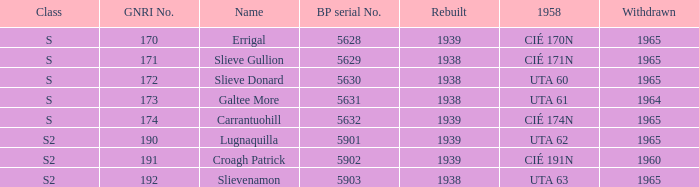What is the smallest withdrawn value with a GNRI greater than 172, name of Croagh Patrick and was rebuilt before 1939? None. 